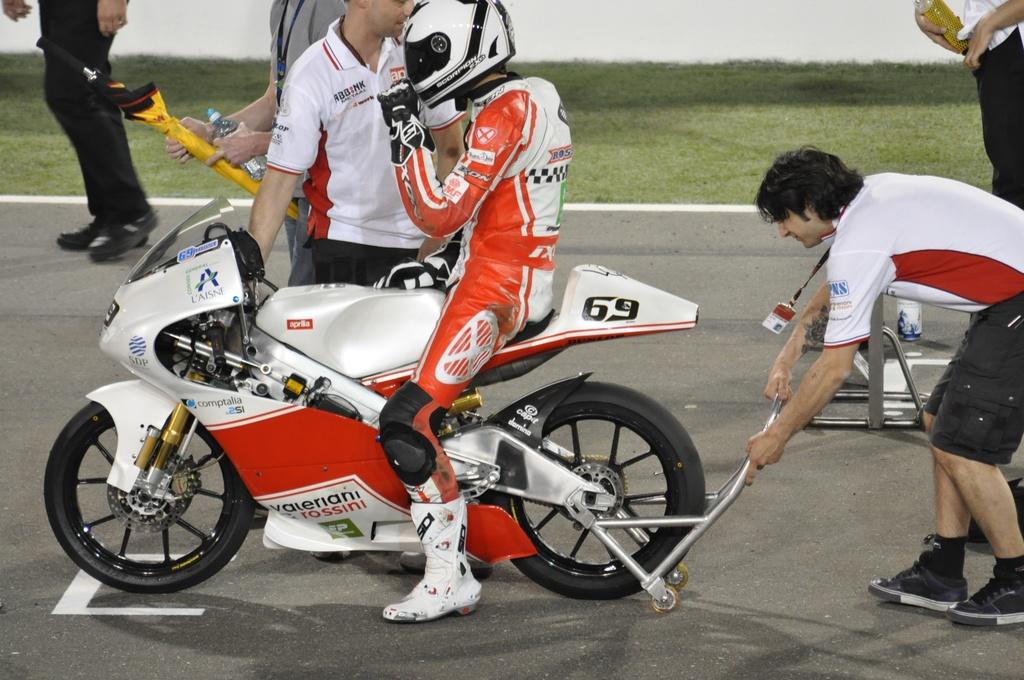What is the main subject of the image? A: The main subject of the image is a motorbike. Who is riding the motorbike? A man is riding the motorbike. What is the man wearing? The man is wearing an orange and white dress. What can be seen in the background of the image? There are people standing in the background of the image. Where are the people standing? The people are standing on the road. Can you see any feathers on the motorbike in the image? No, there are no feathers visible on the motorbike in the image. What type of rice is being served at the van in the image? There is no van or rice present in the image; it features a man riding a motorbike with people standing on the road in the background. 